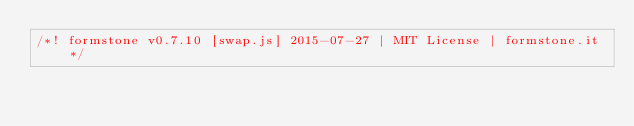<code> <loc_0><loc_0><loc_500><loc_500><_JavaScript_>/*! formstone v0.7.10 [swap.js] 2015-07-27 | MIT License | formstone.it */
</code> 